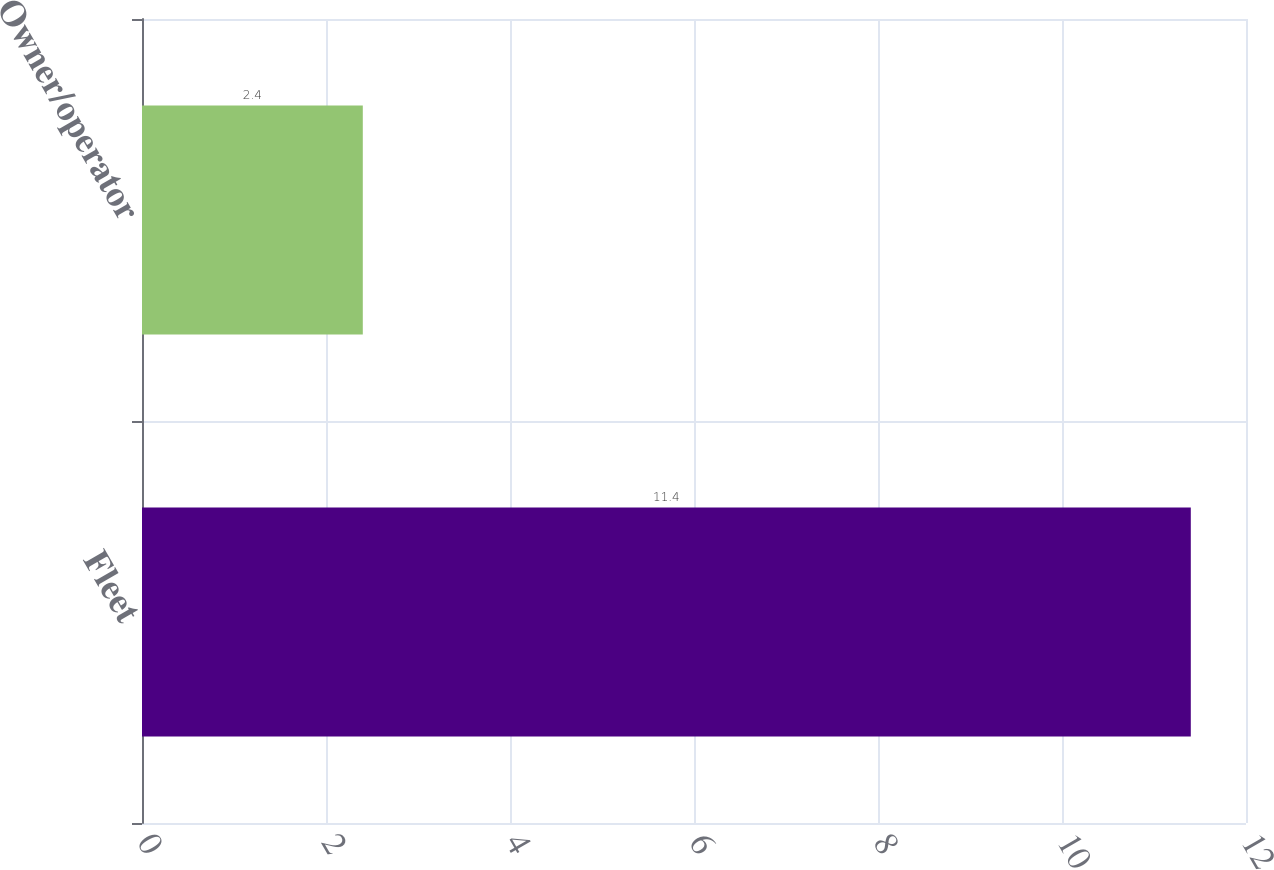<chart> <loc_0><loc_0><loc_500><loc_500><bar_chart><fcel>Fleet<fcel>Owner/operator<nl><fcel>11.4<fcel>2.4<nl></chart> 